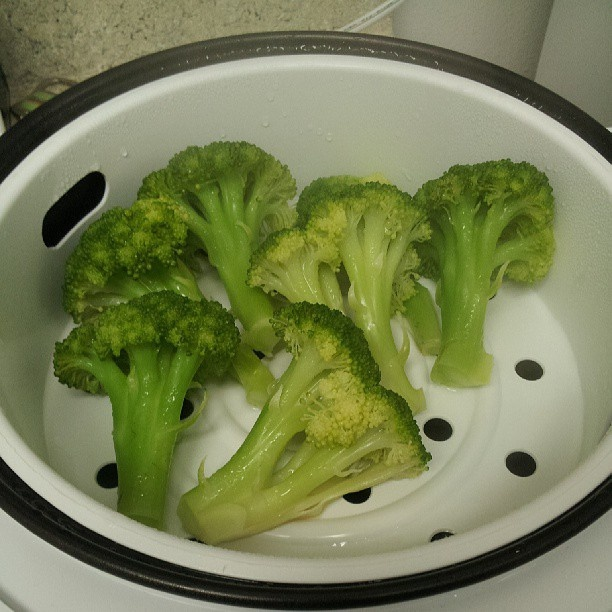Describe the objects in this image and their specific colors. I can see bowl in darkgray, darkgreen, olive, and black tones, broccoli in darkgreen and olive tones, and broccoli in darkgreen and olive tones in this image. 